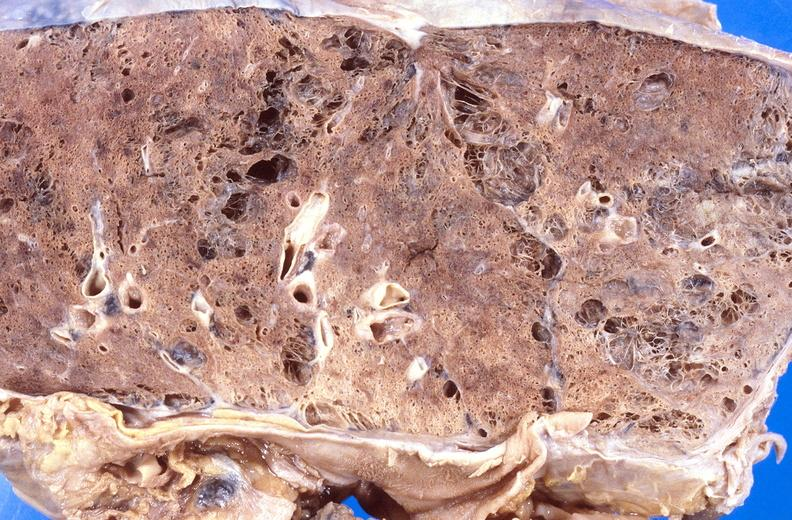what is present?
Answer the question using a single word or phrase. Respiratory 